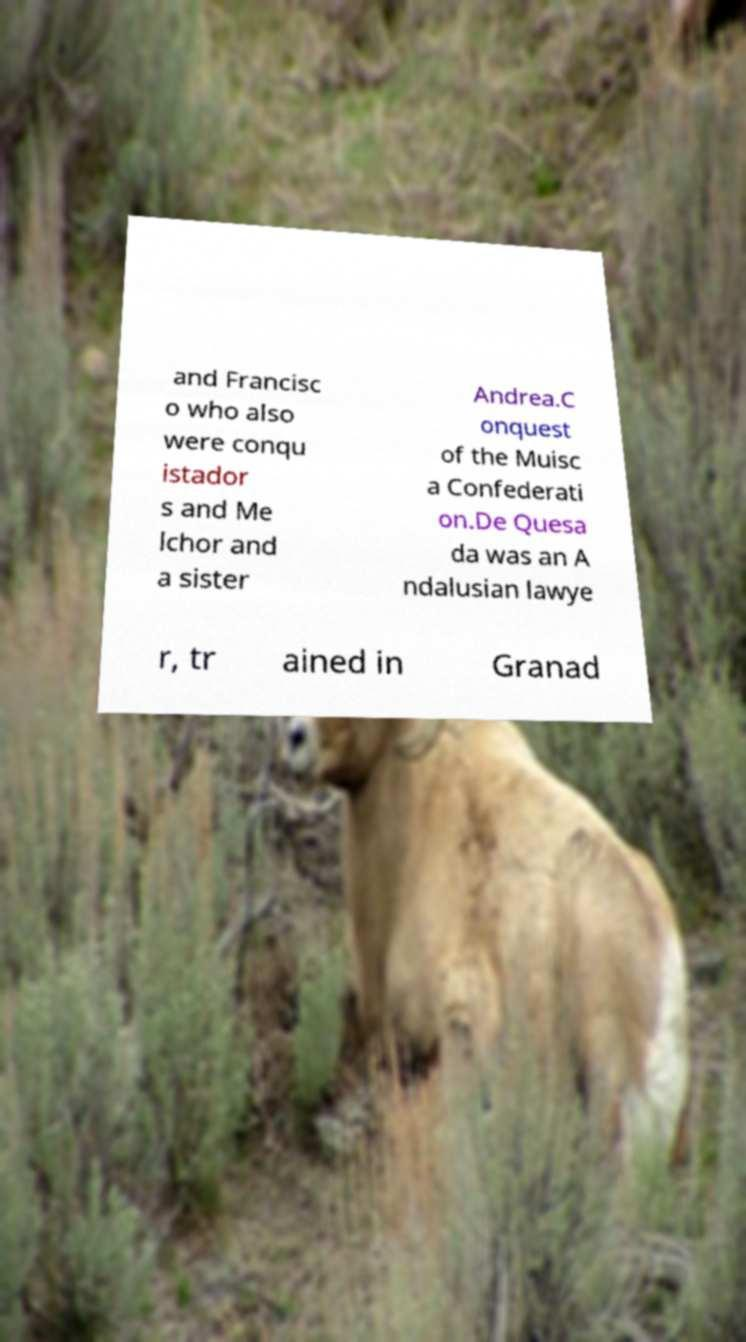There's text embedded in this image that I need extracted. Can you transcribe it verbatim? and Francisc o who also were conqu istador s and Me lchor and a sister Andrea.C onquest of the Muisc a Confederati on.De Quesa da was an A ndalusian lawye r, tr ained in Granad 